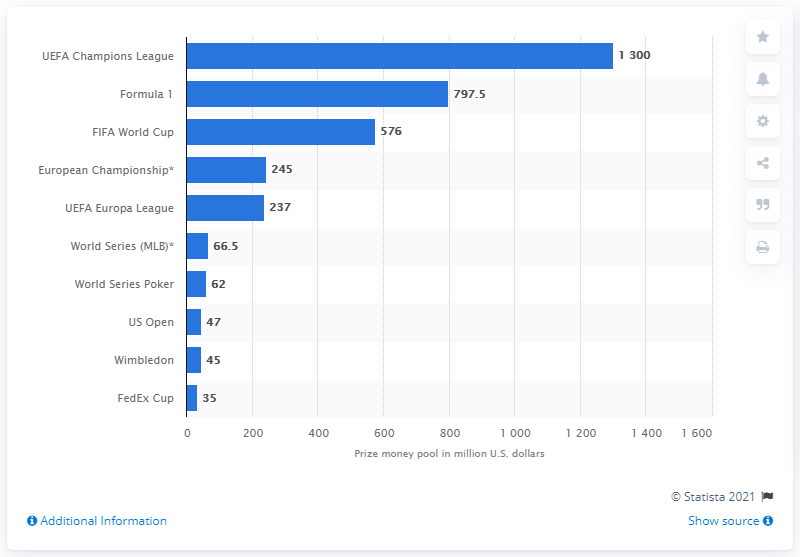Identify some key points in this picture. In 2019, the UEFA Champions League held the highest prize money pool among all sports events. As of 2019, the UEFA Champions League had a total prize money of 1,300 million euros. 